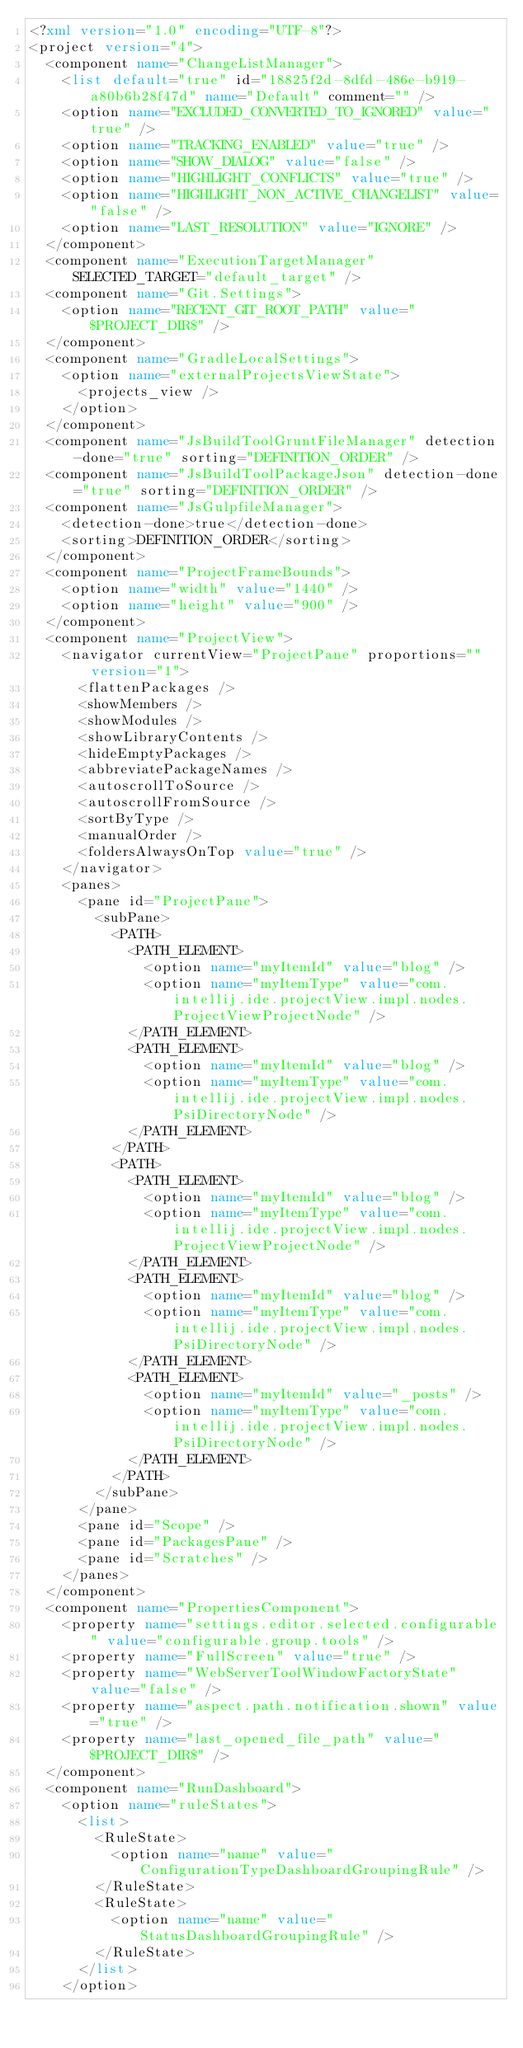<code> <loc_0><loc_0><loc_500><loc_500><_XML_><?xml version="1.0" encoding="UTF-8"?>
<project version="4">
  <component name="ChangeListManager">
    <list default="true" id="18825f2d-8dfd-486e-b919-a80b6b28f47d" name="Default" comment="" />
    <option name="EXCLUDED_CONVERTED_TO_IGNORED" value="true" />
    <option name="TRACKING_ENABLED" value="true" />
    <option name="SHOW_DIALOG" value="false" />
    <option name="HIGHLIGHT_CONFLICTS" value="true" />
    <option name="HIGHLIGHT_NON_ACTIVE_CHANGELIST" value="false" />
    <option name="LAST_RESOLUTION" value="IGNORE" />
  </component>
  <component name="ExecutionTargetManager" SELECTED_TARGET="default_target" />
  <component name="Git.Settings">
    <option name="RECENT_GIT_ROOT_PATH" value="$PROJECT_DIR$" />
  </component>
  <component name="GradleLocalSettings">
    <option name="externalProjectsViewState">
      <projects_view />
    </option>
  </component>
  <component name="JsBuildToolGruntFileManager" detection-done="true" sorting="DEFINITION_ORDER" />
  <component name="JsBuildToolPackageJson" detection-done="true" sorting="DEFINITION_ORDER" />
  <component name="JsGulpfileManager">
    <detection-done>true</detection-done>
    <sorting>DEFINITION_ORDER</sorting>
  </component>
  <component name="ProjectFrameBounds">
    <option name="width" value="1440" />
    <option name="height" value="900" />
  </component>
  <component name="ProjectView">
    <navigator currentView="ProjectPane" proportions="" version="1">
      <flattenPackages />
      <showMembers />
      <showModules />
      <showLibraryContents />
      <hideEmptyPackages />
      <abbreviatePackageNames />
      <autoscrollToSource />
      <autoscrollFromSource />
      <sortByType />
      <manualOrder />
      <foldersAlwaysOnTop value="true" />
    </navigator>
    <panes>
      <pane id="ProjectPane">
        <subPane>
          <PATH>
            <PATH_ELEMENT>
              <option name="myItemId" value="blog" />
              <option name="myItemType" value="com.intellij.ide.projectView.impl.nodes.ProjectViewProjectNode" />
            </PATH_ELEMENT>
            <PATH_ELEMENT>
              <option name="myItemId" value="blog" />
              <option name="myItemType" value="com.intellij.ide.projectView.impl.nodes.PsiDirectoryNode" />
            </PATH_ELEMENT>
          </PATH>
          <PATH>
            <PATH_ELEMENT>
              <option name="myItemId" value="blog" />
              <option name="myItemType" value="com.intellij.ide.projectView.impl.nodes.ProjectViewProjectNode" />
            </PATH_ELEMENT>
            <PATH_ELEMENT>
              <option name="myItemId" value="blog" />
              <option name="myItemType" value="com.intellij.ide.projectView.impl.nodes.PsiDirectoryNode" />
            </PATH_ELEMENT>
            <PATH_ELEMENT>
              <option name="myItemId" value="_posts" />
              <option name="myItemType" value="com.intellij.ide.projectView.impl.nodes.PsiDirectoryNode" />
            </PATH_ELEMENT>
          </PATH>
        </subPane>
      </pane>
      <pane id="Scope" />
      <pane id="PackagesPane" />
      <pane id="Scratches" />
    </panes>
  </component>
  <component name="PropertiesComponent">
    <property name="settings.editor.selected.configurable" value="configurable.group.tools" />
    <property name="FullScreen" value="true" />
    <property name="WebServerToolWindowFactoryState" value="false" />
    <property name="aspect.path.notification.shown" value="true" />
    <property name="last_opened_file_path" value="$PROJECT_DIR$" />
  </component>
  <component name="RunDashboard">
    <option name="ruleStates">
      <list>
        <RuleState>
          <option name="name" value="ConfigurationTypeDashboardGroupingRule" />
        </RuleState>
        <RuleState>
          <option name="name" value="StatusDashboardGroupingRule" />
        </RuleState>
      </list>
    </option></code> 